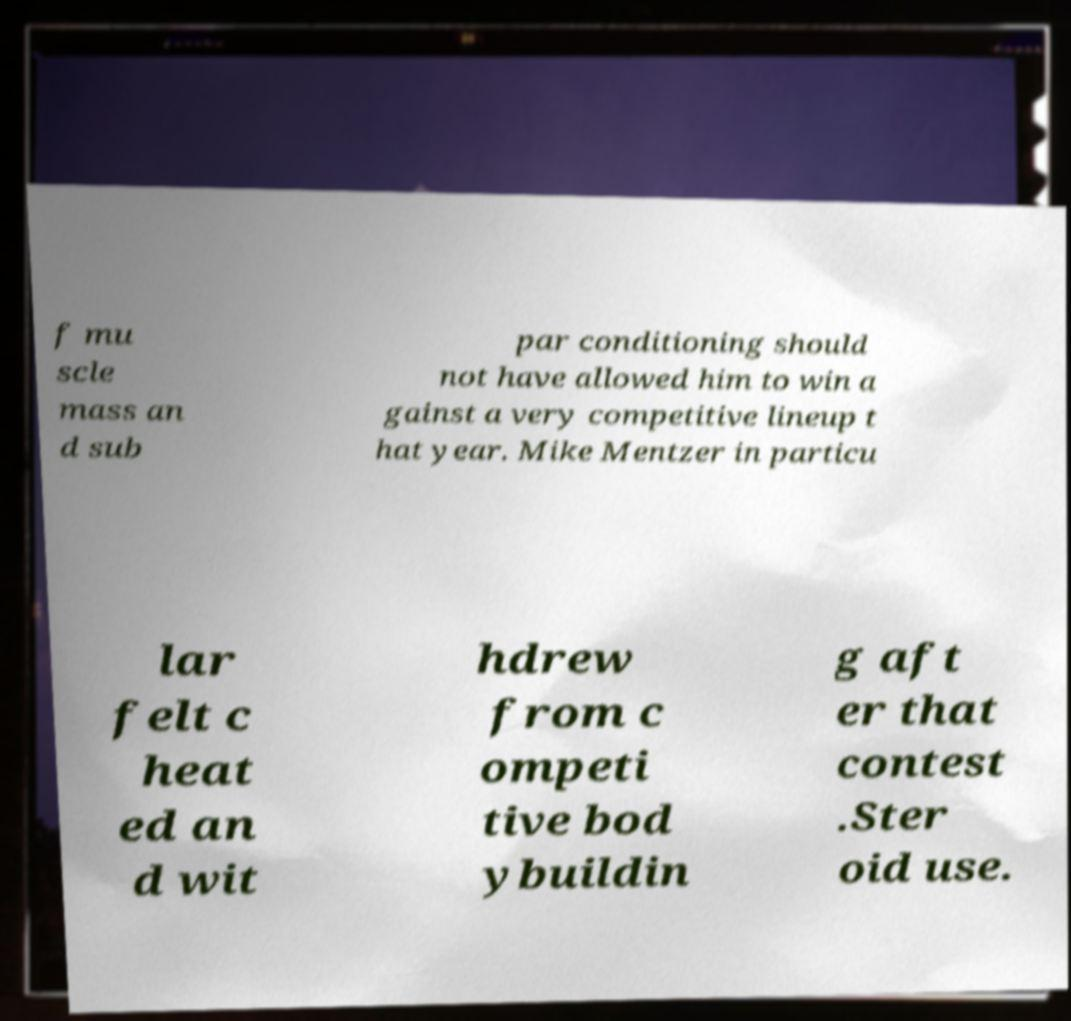What messages or text are displayed in this image? I need them in a readable, typed format. f mu scle mass an d sub par conditioning should not have allowed him to win a gainst a very competitive lineup t hat year. Mike Mentzer in particu lar felt c heat ed an d wit hdrew from c ompeti tive bod ybuildin g aft er that contest .Ster oid use. 